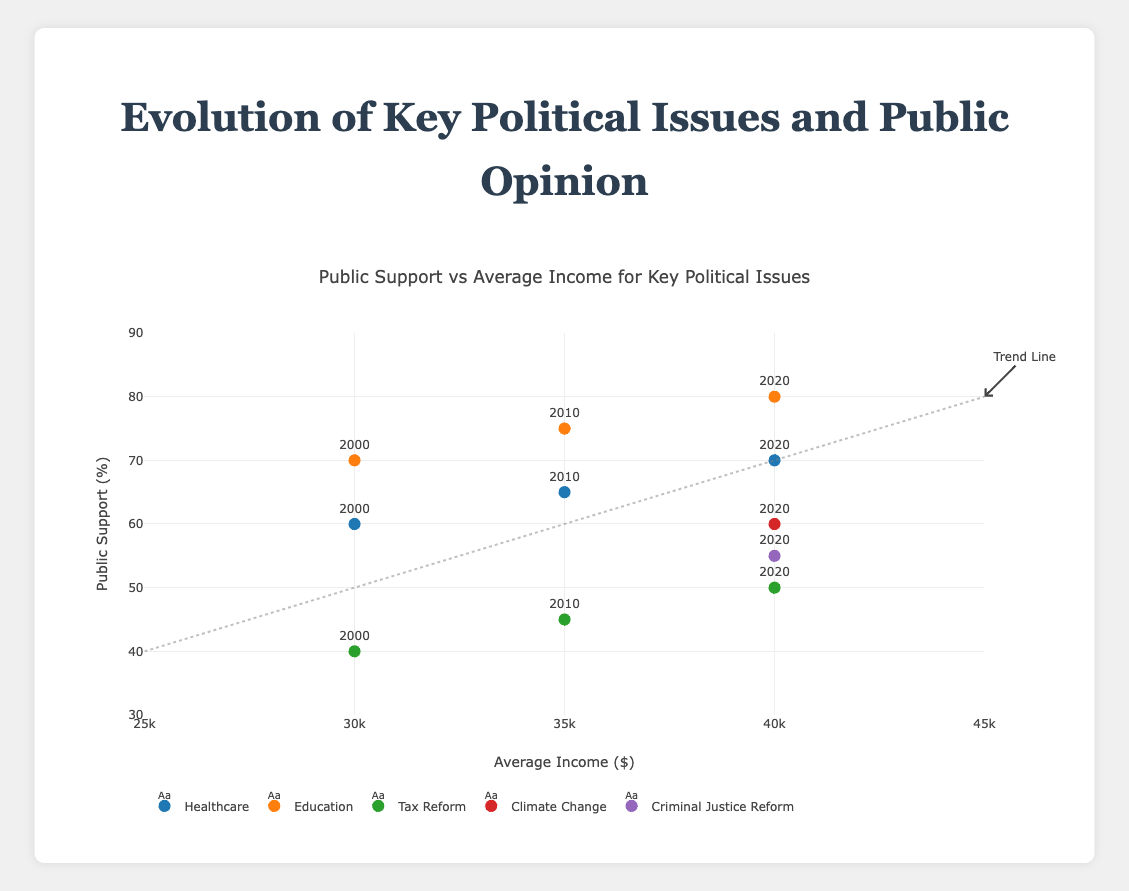What is the title of the figure? The title of the figure can be found at the top center of the plot.
Answer: Public Support vs Average Income for Key Political Issues What is the range of the x-axis in the plot? The x-axis represents the average income, and its range can be determined by observing the axis labels, which go from $25,000 to $45,000.
Answer: $25,000 to $45,000 How many key political issues are represented in the figure? The key issues can be identified by the different legends in the plot. Upon examining, there are 5 distinct key issues (Healthcare, Education, Tax Reform, Climate Change, and Criminal Justice Reform).
Answer: 5 Which key political issue has the highest public support percentage in 2020, and what is that percentage? By observing the data points for the year 2020 and comparing their heights on the y-axis, Education has the highest public support percentage at 80%.
Answer: Education, 80% By how much did the public support for Healthcare change from 2000 to 2020? To determine the change, subtract the 2000 public support percentage (60) from the 2020 public support percentage (70).
Answer: 10% Which key political issue shows the least increase in public support from 2000 to 2020? Compare the increase in percentages for each key issue between 2000 and 2020. Tax Reform increased the least, from 40% to 50%, which is a 10% increase.
Answer: Tax Reform What is the trend line indicating in terms of public support and average income? The trend line shows a positive relationship, meaning that as average income increases from $25,000 to $45,000, the public support percentage tends to increase from 40% to 80%.
Answer: Positive relationship Are there any new key political issues introduced in 2020 compared to 2000 and 2010, and if so, what are they? By observing the legends and the years associated with each data point, we see that Climate Change and Criminal Justice Reform are new issues introduced in 2020.
Answer: Climate Change, Criminal Justice Reform Which key political issue has a trend closest to the trend line, and what does it imply? By visually comparing the markers to the trend line, Education's data points from 2000, 2010, and 2020 are closest to the trend line, implying that its relationship with average income follows the general positive trend across the years.
Answer: Education How does the public support for Climate Change in 2020 compare with Tax Reform in 2020? By looking at the y-axis values for Climate Change and Tax Reform in 2020, Climate Change has 60% public support, while Tax Reform has 50%. Thus, Climate Change has higher public support in 2020.
Answer: Climate Change higher by 10% 